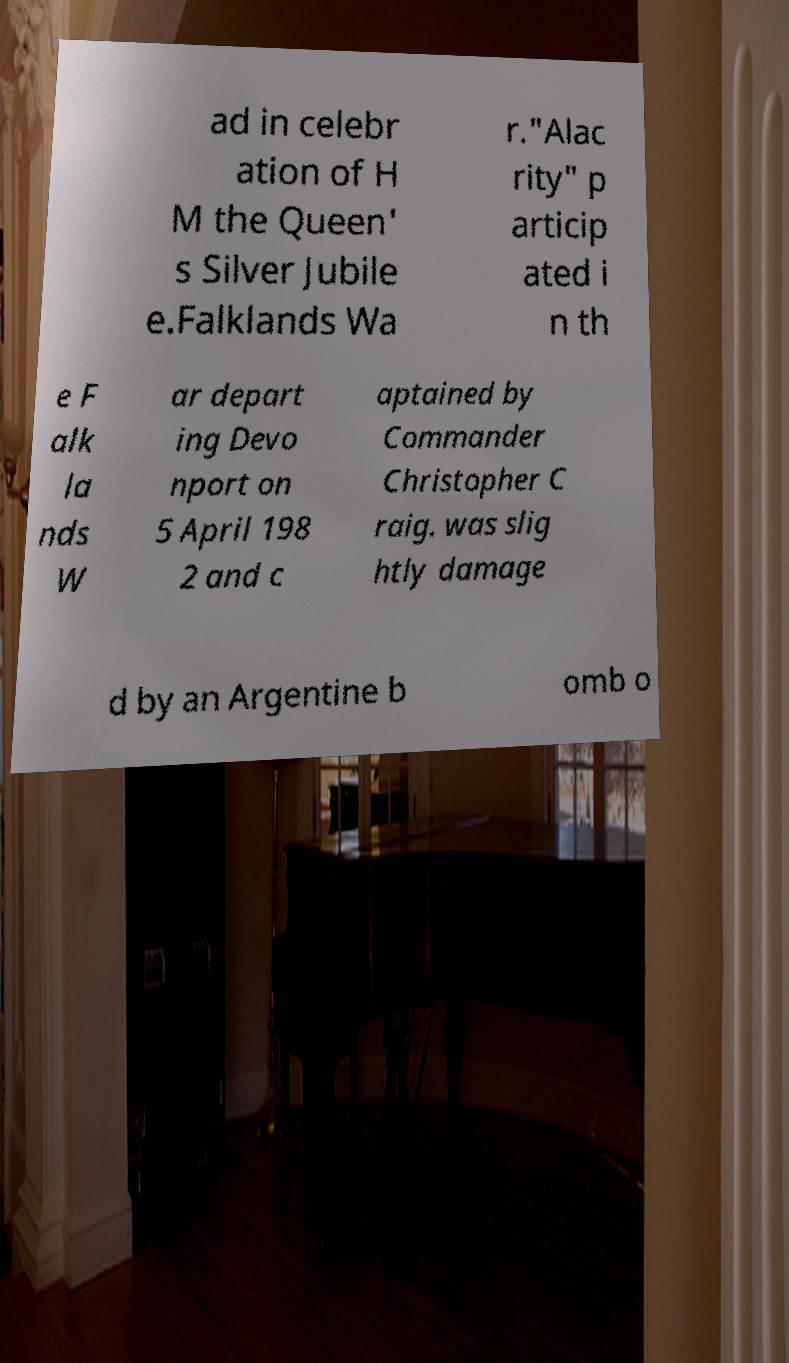Can you read and provide the text displayed in the image?This photo seems to have some interesting text. Can you extract and type it out for me? ad in celebr ation of H M the Queen' s Silver Jubile e.Falklands Wa r."Alac rity" p articip ated i n th e F alk la nds W ar depart ing Devo nport on 5 April 198 2 and c aptained by Commander Christopher C raig. was slig htly damage d by an Argentine b omb o 